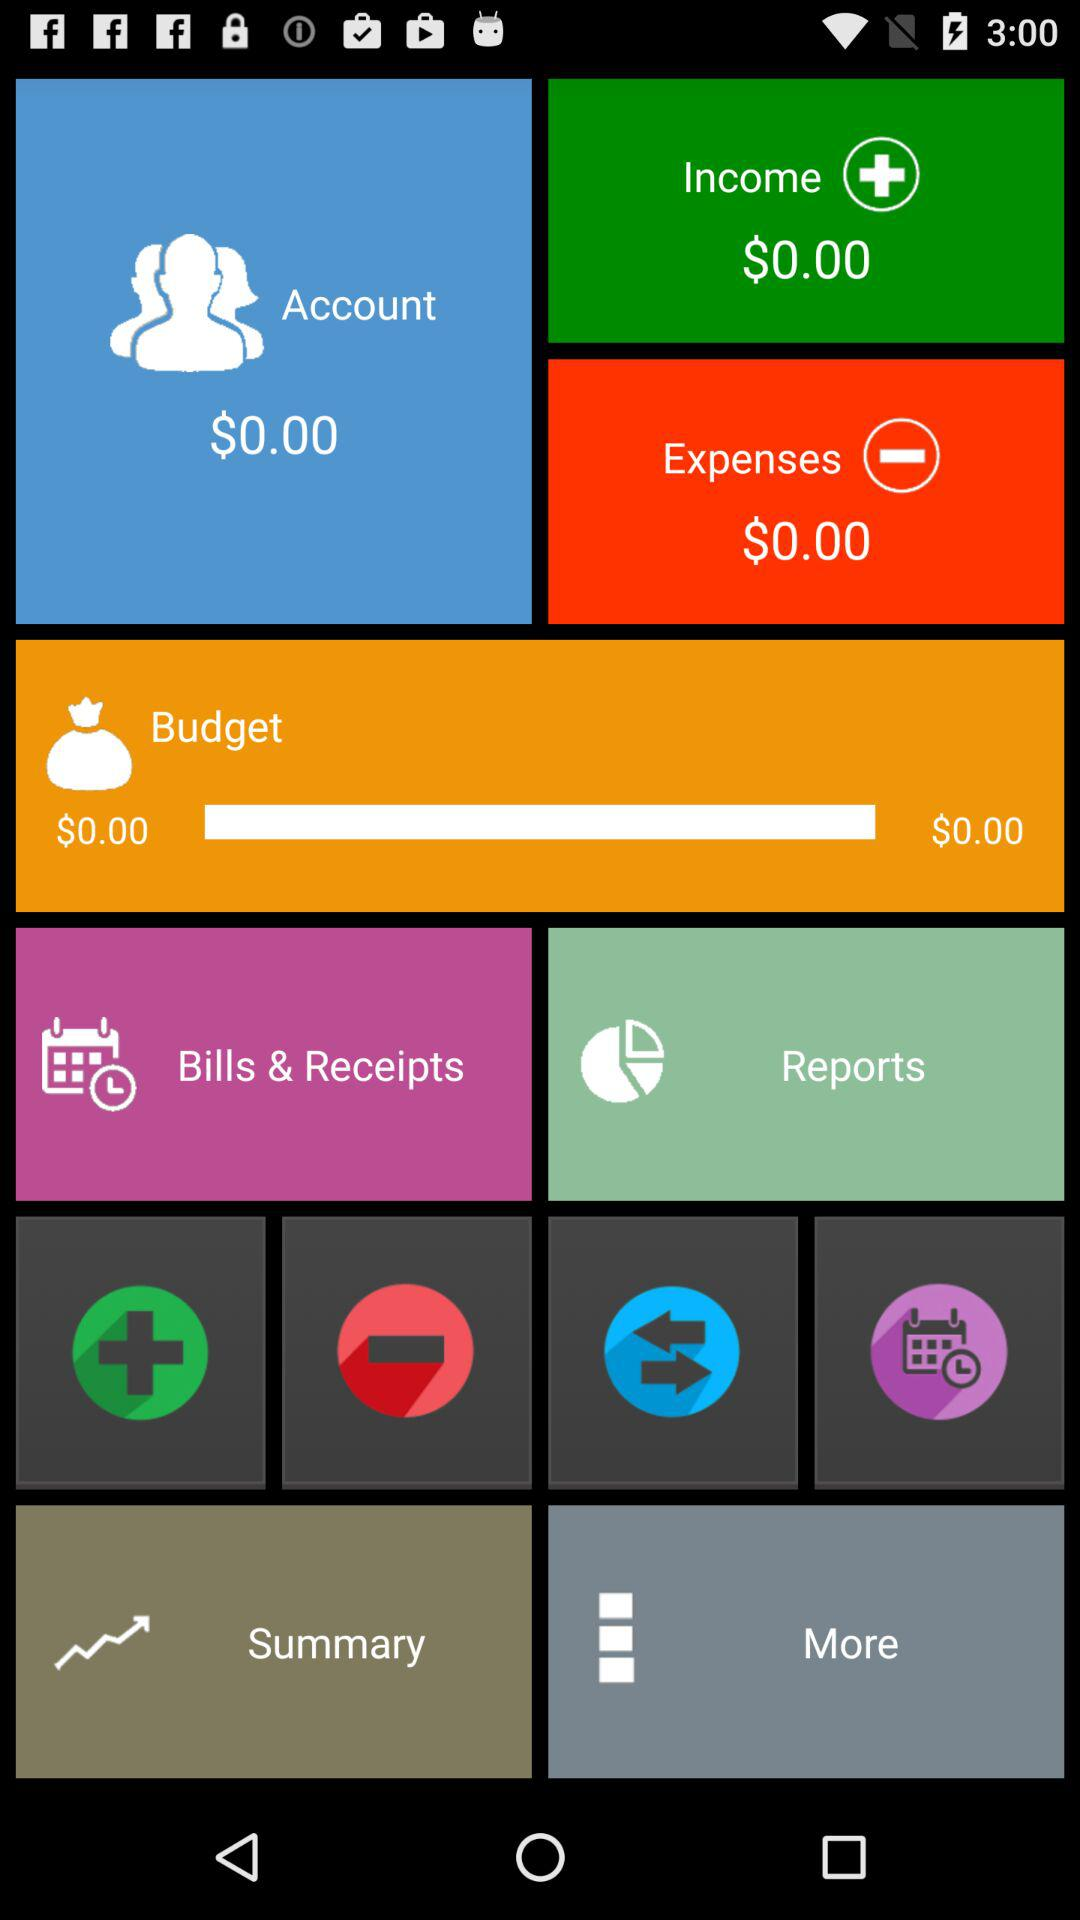How much is the budget?
Answer the question using a single word or phrase. $0.00 